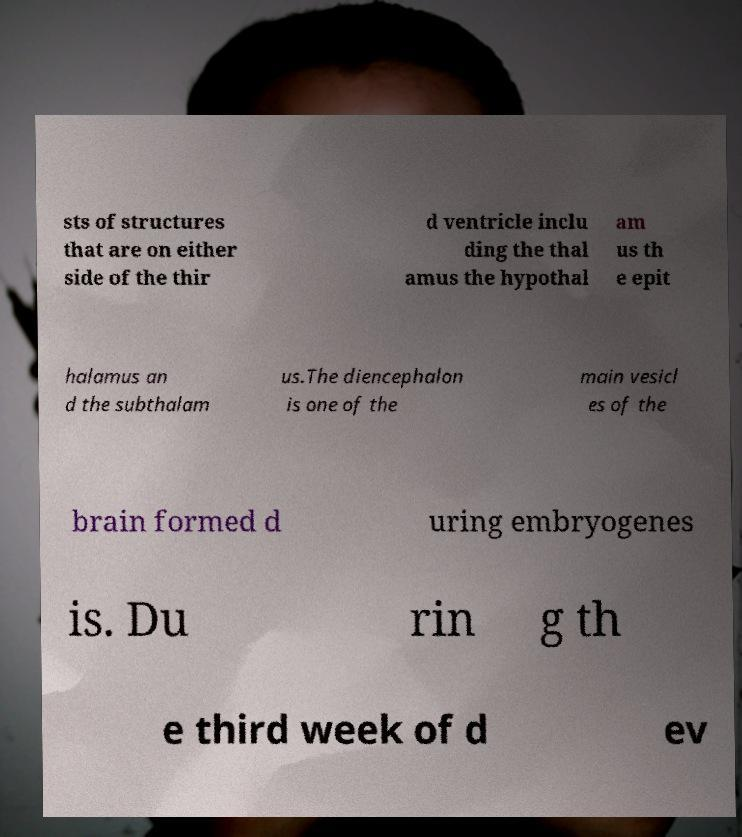I need the written content from this picture converted into text. Can you do that? sts of structures that are on either side of the thir d ventricle inclu ding the thal amus the hypothal am us th e epit halamus an d the subthalam us.The diencephalon is one of the main vesicl es of the brain formed d uring embryogenes is. Du rin g th e third week of d ev 